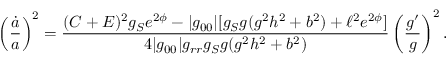<formula> <loc_0><loc_0><loc_500><loc_500>\left ( { \frac { \dot { a } } { a } } \right ) ^ { 2 } = { \frac { ( C + E ) ^ { 2 } g _ { S } e ^ { 2 \phi } - | g _ { 0 0 } | [ g _ { S } g ( g ^ { 2 } h ^ { 2 } + b ^ { 2 } ) + \ell ^ { 2 } e ^ { 2 \phi } ] } { 4 | g _ { 0 0 } | g _ { r r } g _ { S } g ( g ^ { 2 } h ^ { 2 } + b ^ { 2 } ) } } \left ( { \frac { g ^ { \prime } } { g } } \right ) ^ { 2 } .</formula> 